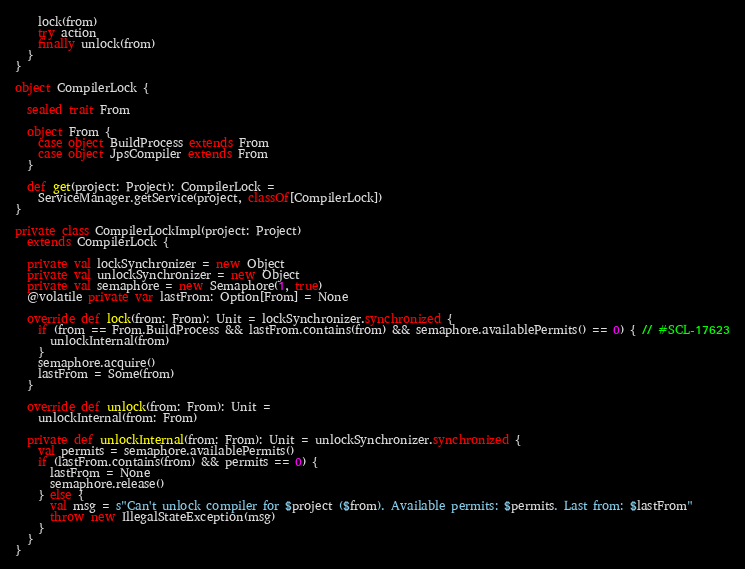Convert code to text. <code><loc_0><loc_0><loc_500><loc_500><_Scala_>    lock(from)
    try action
    finally unlock(from)
  }
}

object CompilerLock {
  
  sealed trait From
  
  object From {
    case object BuildProcess extends From
    case object JpsCompiler extends From
  }

  def get(project: Project): CompilerLock =
    ServiceManager.getService(project, classOf[CompilerLock])
}

private class CompilerLockImpl(project: Project)
  extends CompilerLock {

  private val lockSynchronizer = new Object
  private val unlockSynchronizer = new Object
  private val semaphore = new Semaphore(1, true)
  @volatile private var lastFrom: Option[From] = None
  
  override def lock(from: From): Unit = lockSynchronizer.synchronized {
    if (from == From.BuildProcess && lastFrom.contains(from) && semaphore.availablePermits() == 0) { // #SCL-17623
      unlockInternal(from)
    }
    semaphore.acquire()
    lastFrom = Some(from)
  }

  override def unlock(from: From): Unit =
    unlockInternal(from: From)
  
  private def unlockInternal(from: From): Unit = unlockSynchronizer.synchronized {
    val permits = semaphore.availablePermits()
    if (lastFrom.contains(from) && permits == 0) {
      lastFrom = None
      semaphore.release()
    } else {
      val msg = s"Can't unlock compiler for $project ($from). Available permits: $permits. Last from: $lastFrom"
      throw new IllegalStateException(msg)
    }
  }
}
</code> 